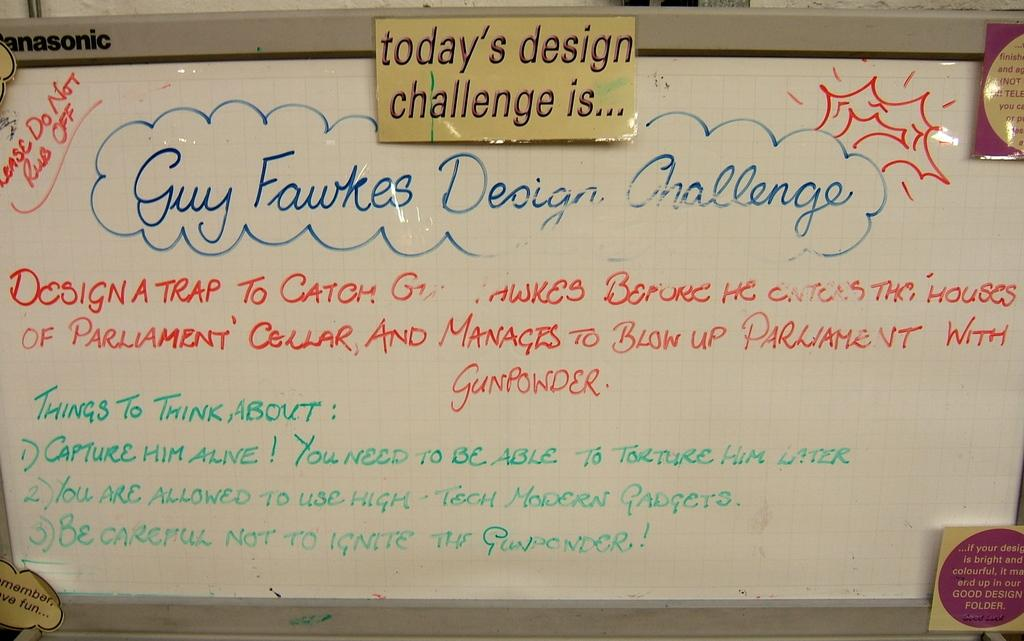Provide a one-sentence caption for the provided image. A white dry erase board with a daily challenge and thoughts for the day written on it. 